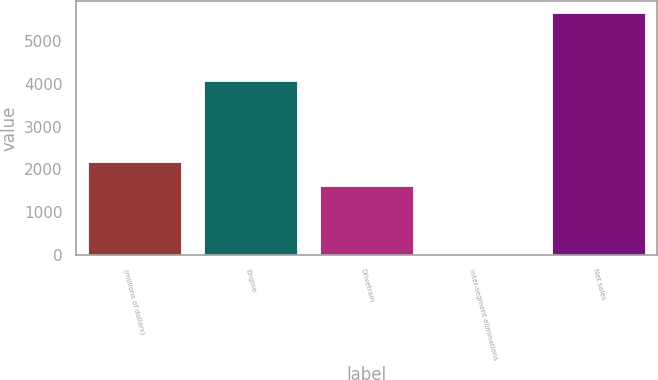Convert chart to OTSL. <chart><loc_0><loc_0><loc_500><loc_500><bar_chart><fcel>(millions of dollars)<fcel>Engine<fcel>Drivetrain<fcel>Inter-segment eliminations<fcel>Net sales<nl><fcel>2174.74<fcel>4060.8<fcel>1611.4<fcel>19.4<fcel>5652.8<nl></chart> 